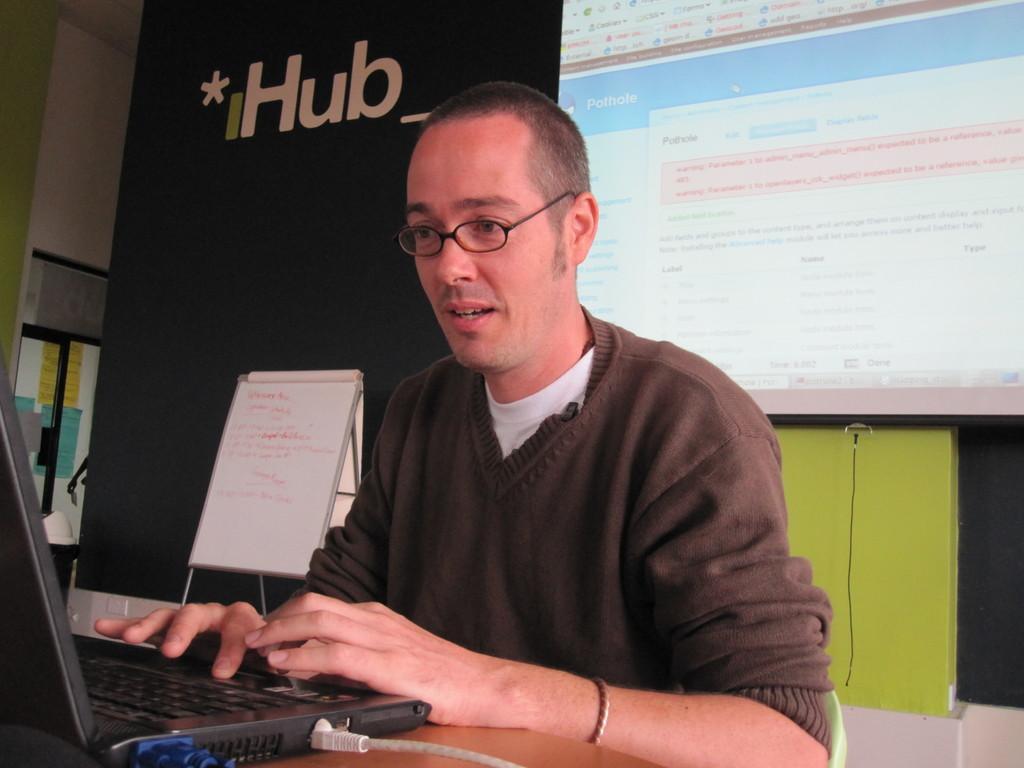Describe this image in one or two sentences. In this image we can see one person sitting, beside that we can see an electronic gadget on the table. And we can see text written on the board, beside that we can see display with some text written on it, towards that we can see cable wire, on the left we can see the window. 